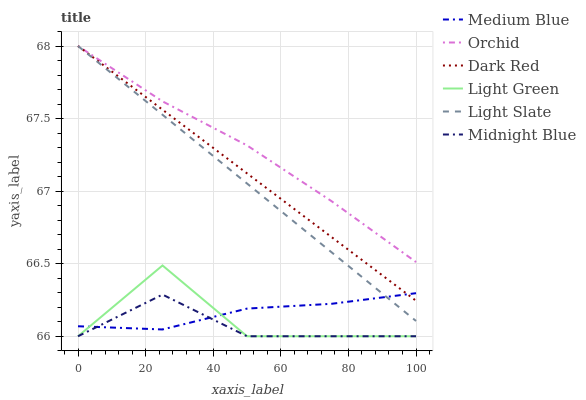Does Light Slate have the minimum area under the curve?
Answer yes or no. No. Does Light Slate have the maximum area under the curve?
Answer yes or no. No. Is Medium Blue the smoothest?
Answer yes or no. No. Is Medium Blue the roughest?
Answer yes or no. No. Does Light Slate have the lowest value?
Answer yes or no. No. Does Medium Blue have the highest value?
Answer yes or no. No. Is Midnight Blue less than Dark Red?
Answer yes or no. Yes. Is Orchid greater than Medium Blue?
Answer yes or no. Yes. Does Midnight Blue intersect Dark Red?
Answer yes or no. No. 